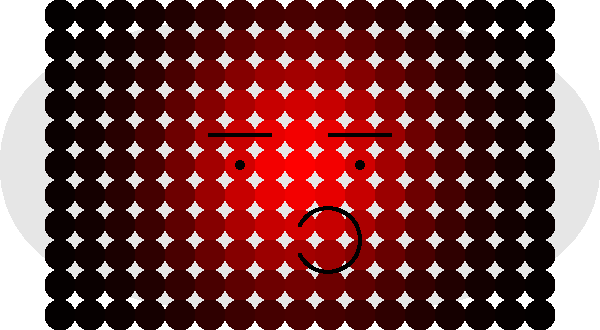Analyze the facial recognition heat map provided for two different hat styles: a fedora and a beanie. Which facial features appear to have the highest correlation with hat style selection, and how might this information be used in personalized hat recommendations? To analyze the correlation between hat styles and facial features using the facial recognition heat map, we need to follow these steps:

1. Observe the heat map: The red areas indicate higher correlation or importance for facial recognition.

2. Identify key areas:
   a. Upper forehead: High intensity for both hat styles
   b. Cheekbones: Moderate intensity for both styles
   c. Nose bridge: Higher intensity for the fedora
   d. Jawline: Higher intensity for the beanie

3. Interpret the results:
   a. The upper forehead is crucial for both hat styles, likely due to how hats sit on the head.
   b. The fedora shows higher correlation with the nose bridge, suggesting it may be more suitable for those with prominent nose bridges.
   c. The beanie shows higher correlation with the jawline, indicating it may be more flattering for those with defined jaw structures.

4. Application to personalized recommendations:
   a. For individuals with prominent nose bridges, recommend fedoras or similar structured hats.
   b. For those with defined jawlines, suggest beanies or softer, more flexible hat styles.
   c. Consider the overall face shape when making recommendations, as the heat map shows correlation across multiple facial features.

5. Additional considerations:
   a. Use facial recognition software to analyze a customer's facial features.
   b. Develop an algorithm that matches facial feature intensities with suitable hat styles.
   c. Implement a recommendation system in e-commerce platforms or in-store technologies.

By leveraging this facial recognition data, fashion bloggers and retailers can provide more accurate and personalized hat recommendations, potentially increasing customer satisfaction and sales.
Answer: Upper forehead, nose bridge (fedora), and jawline (beanie) show highest correlation; use for personalized hat recommendations based on facial features. 